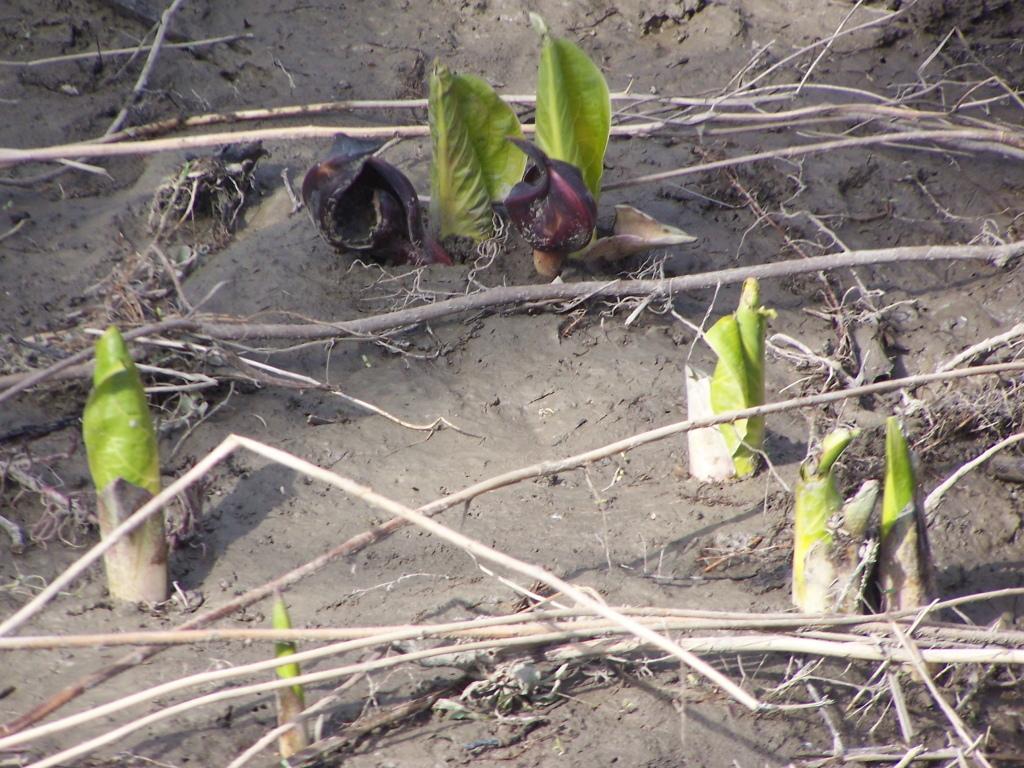How would you summarize this image in a sentence or two? In this image, we can see some green leaves which are on the land, we can also see some wood stem on the land. 